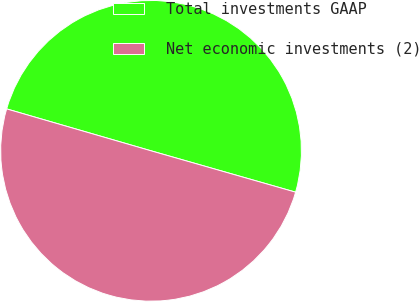<chart> <loc_0><loc_0><loc_500><loc_500><pie_chart><fcel>Total investments GAAP<fcel>Net economic investments (2)<nl><fcel>49.94%<fcel>50.06%<nl></chart> 